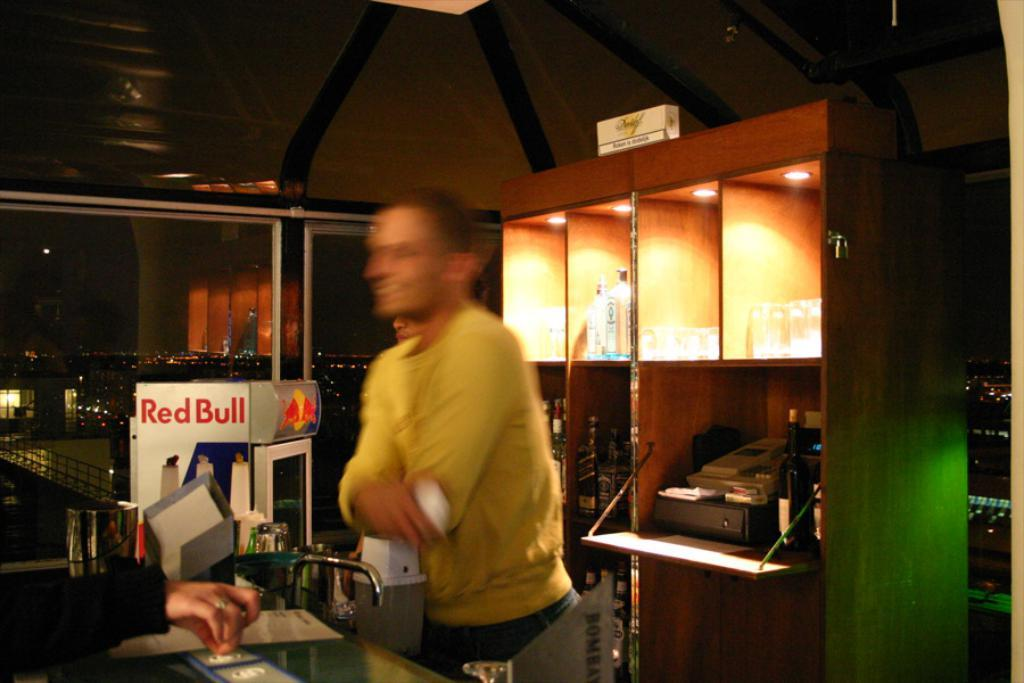<image>
Describe the image concisely. Man in front of a sink next to a Red Bull fridge. 